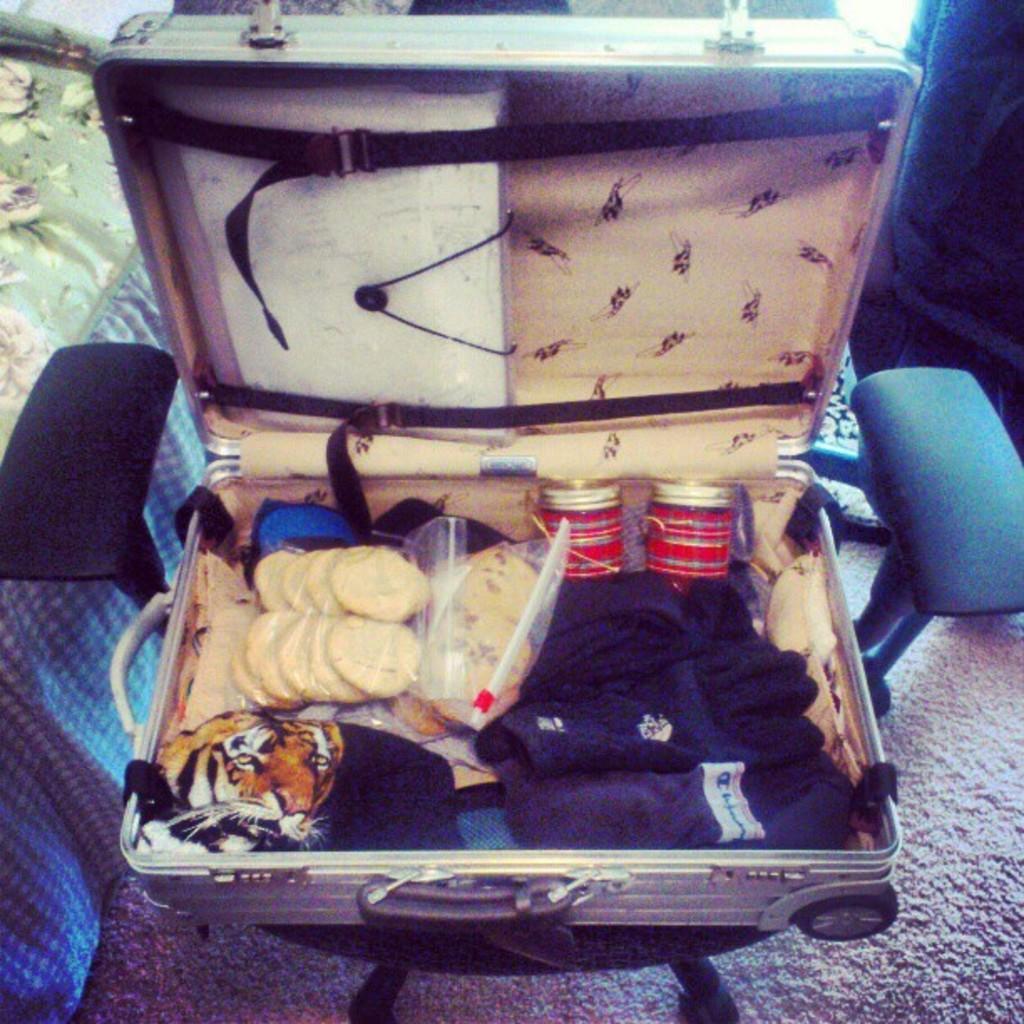In one or two sentences, can you explain what this image depicts? In this picture we can see a suitcase which is placed on chair, suitcase consists of pack of biscuits and some clothes and also suitcase consist of two straps and we can see wheel here. 